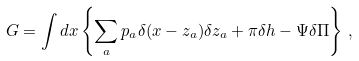Convert formula to latex. <formula><loc_0><loc_0><loc_500><loc_500>G = \int d x \left \{ \sum _ { a } p _ { a } \delta ( x - z _ { a } ) \delta z _ { a } + \pi \delta h - \Psi \delta \Pi \right \} \, ,</formula> 